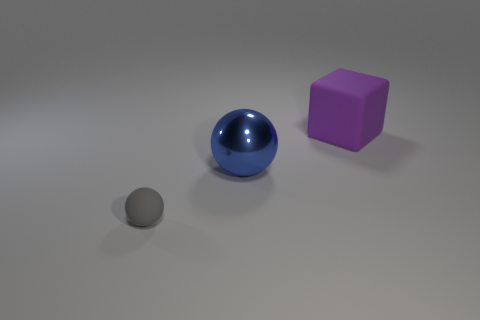Add 3 tiny things. How many objects exist? 6 Subtract all cubes. How many objects are left? 2 Subtract 0 yellow cubes. How many objects are left? 3 Subtract all small gray rubber things. Subtract all gray things. How many objects are left? 1 Add 2 big blocks. How many big blocks are left? 3 Add 2 metallic things. How many metallic things exist? 3 